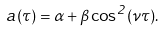<formula> <loc_0><loc_0><loc_500><loc_500>a ( \tau ) = \alpha + \beta \cos ^ { 2 } ( \nu \tau ) .</formula> 